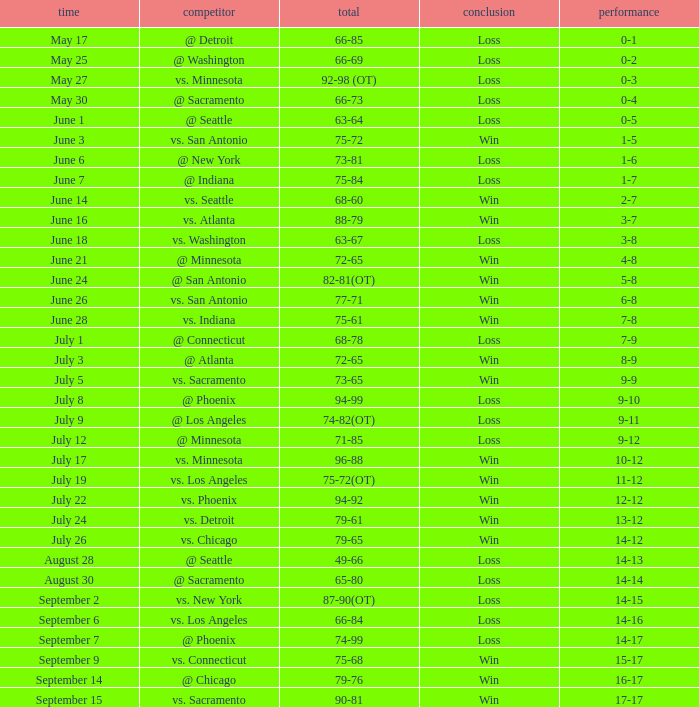What was the Score of the game with a Record of 0-1? 66-85. 